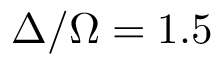<formula> <loc_0><loc_0><loc_500><loc_500>\Delta / \Omega = 1 . 5</formula> 